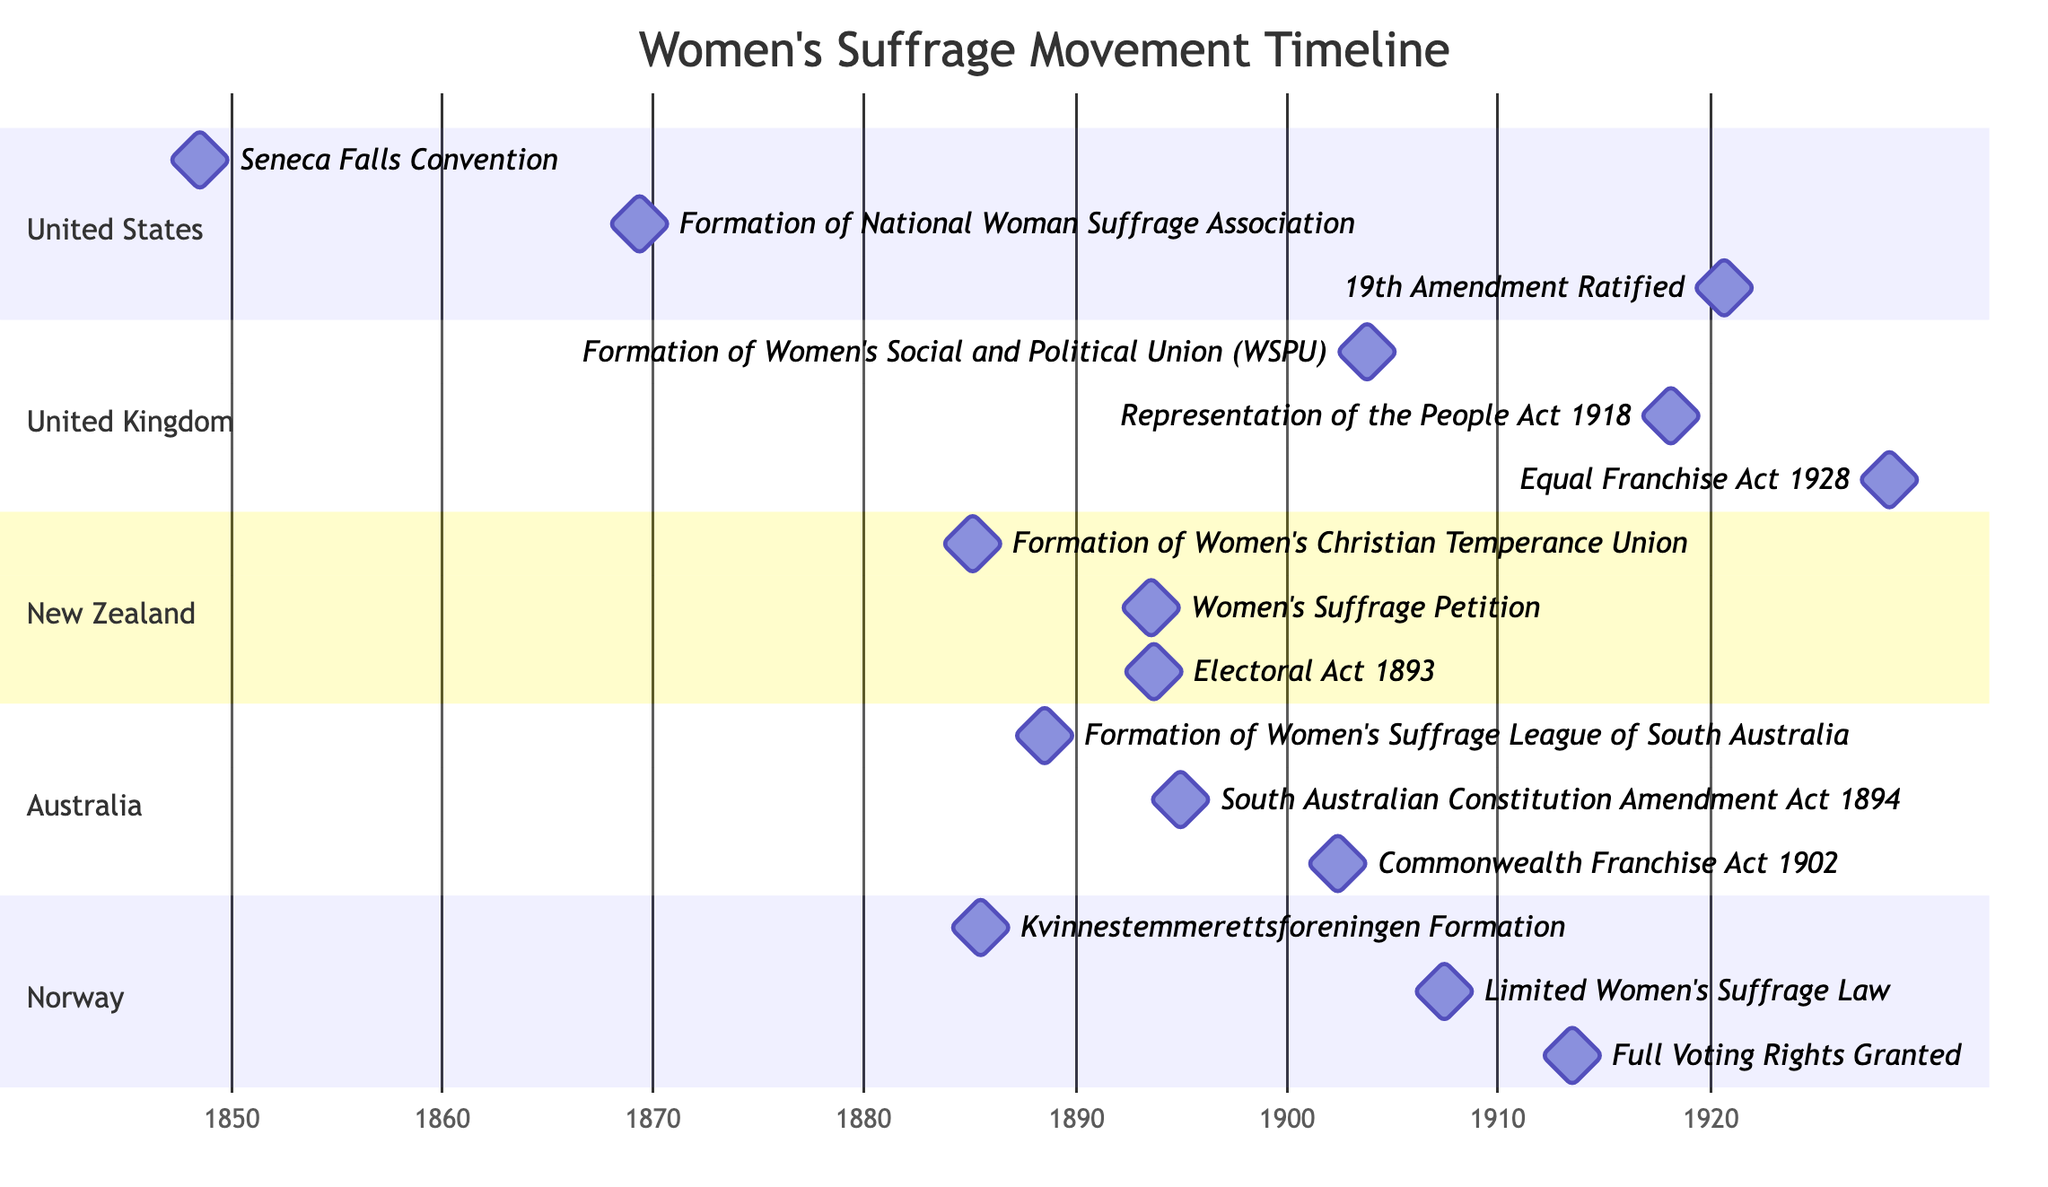What was the first major event in the United States related to women's suffrage? The diagram shows the first milestone in the section for the United States, which is the "Seneca Falls Convention" on July 19, 1848.
Answer: Seneca Falls Convention How many major events are listed for Norway? By reviewing the section for Norway, there are three milestones indicated: "Kvinnestemmerettsforeningen Formation," "Limited Women's Suffrage Law," and "Full Voting Rights Granted." Thus, the total count is three.
Answer: 3 Which Act was passed in the United Kingdom in 1918? The 1918 milestone in the United Kingdom section is labeled as the "Representation of the People Act 1918."
Answer: Representation of the People Act 1918 When did New Zealand grant women the electoral act? Upon examining the New Zealand section, the milestone "Electoral Act 1893" is dated September 19, 1893, indicating when women were granted voting rights.
Answer: Electoral Act 1893 What year was the Women's Suffrage League of South Australia formed? Looking into the Australia's section, the milestone showing the formation of the "Women's Suffrage League of South Australia" is dated July 18, 1888.
Answer: 1888 Which country achieved full voting rights for women first? By comparing milestones from all countries listed, Norway's "Full Voting Rights Granted" is noted on June 11, 1913, which is earlier than other countries listed.
Answer: Norway How many significant acts or formations took place in the 1900s for the United Kingdom? The timeline for the United Kingdom indicates two major events: "Formation of Women's Social and Political Union (WSPU)" in 1903 and "Representation of the People Act 1918" in 1918. This counts to two events.
Answer: 2 What was the milestone event of 1902 in Australia? In the Australian section, "Commonwealth Franchise Act 1902" is listed as the milestone for the year 1902, marking an important legislative event.
Answer: Commonwealth Franchise Act 1902 